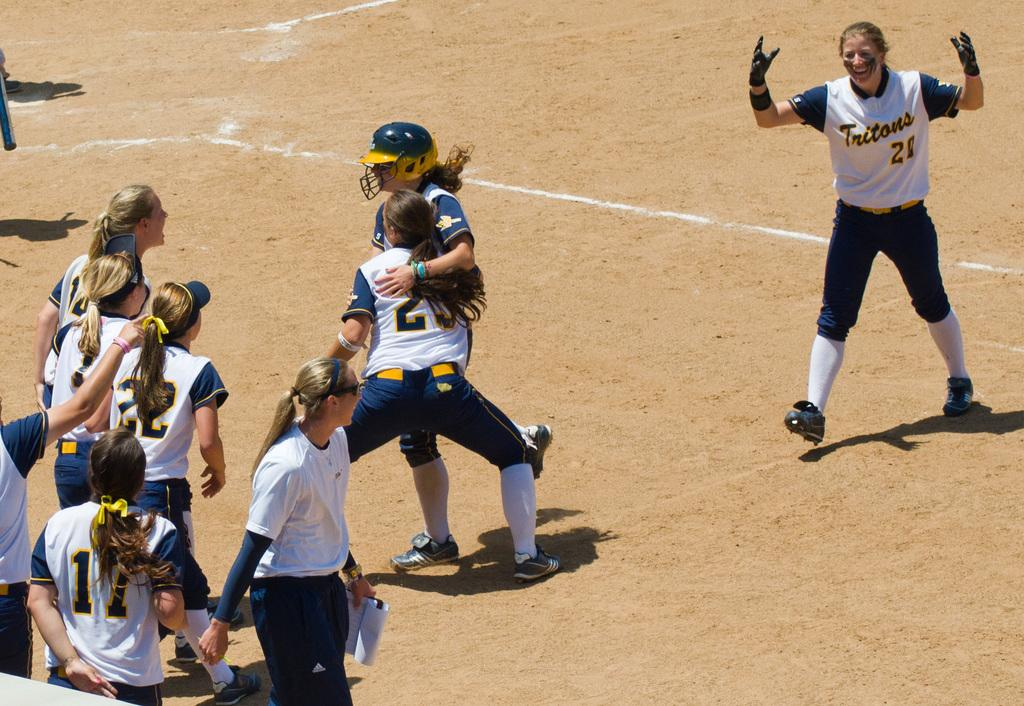<image>
Share a concise interpretation of the image provided. Some sports players, one of whom has the number 11 on her shirt. 